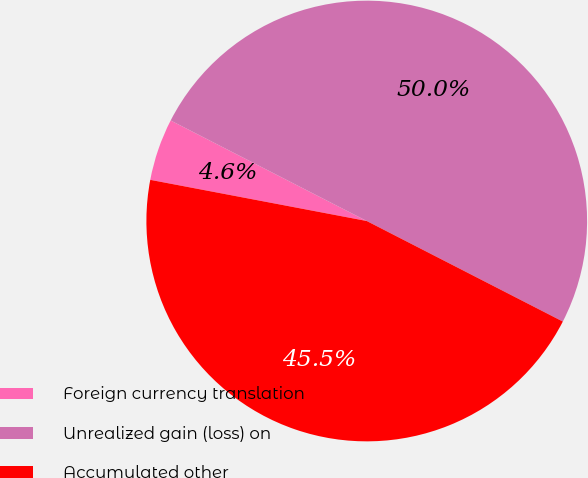Convert chart. <chart><loc_0><loc_0><loc_500><loc_500><pie_chart><fcel>Foreign currency translation<fcel>Unrealized gain (loss) on<fcel>Accumulated other<nl><fcel>4.55%<fcel>50.0%<fcel>45.45%<nl></chart> 